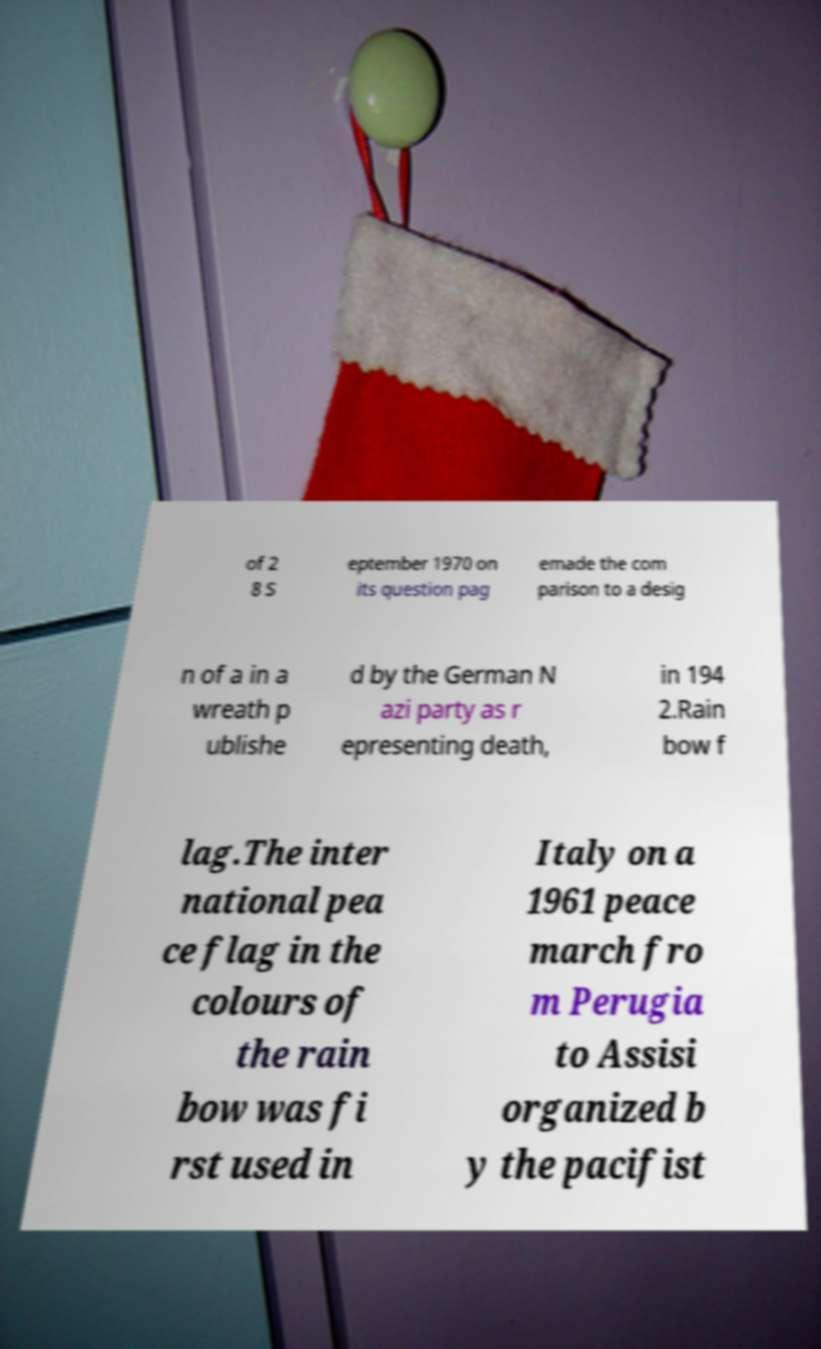I need the written content from this picture converted into text. Can you do that? of 2 8 S eptember 1970 on its question pag emade the com parison to a desig n of a in a wreath p ublishe d by the German N azi party as r epresenting death, in 194 2.Rain bow f lag.The inter national pea ce flag in the colours of the rain bow was fi rst used in Italy on a 1961 peace march fro m Perugia to Assisi organized b y the pacifist 